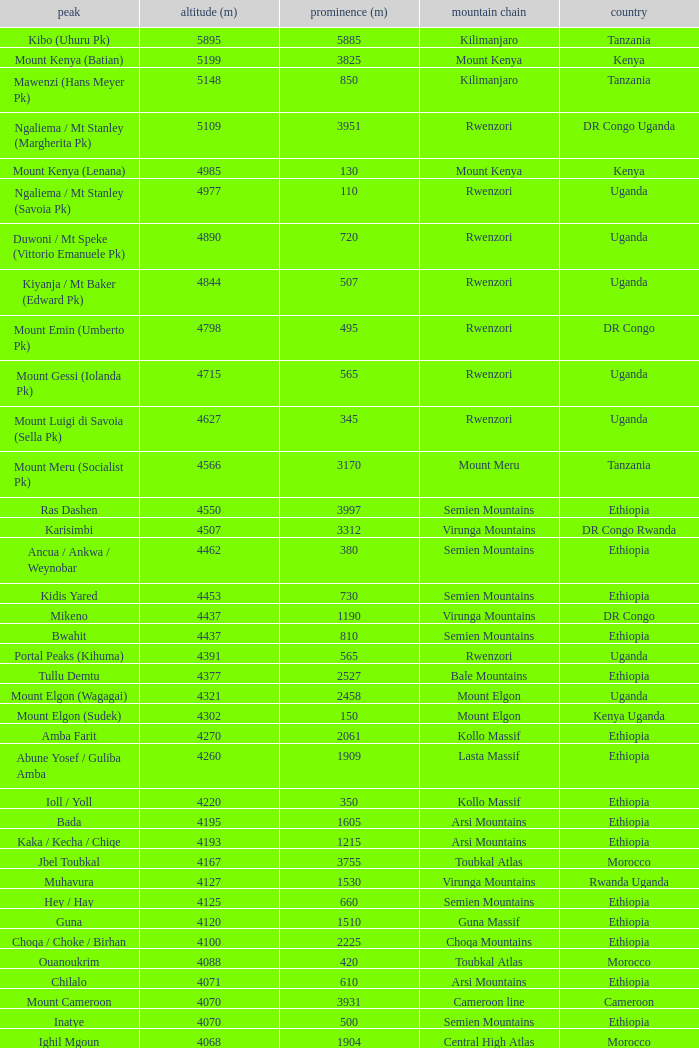Help me parse the entirety of this table. {'header': ['peak', 'altitude (m)', 'prominence (m)', 'mountain chain', 'country'], 'rows': [['Kibo (Uhuru Pk)', '5895', '5885', 'Kilimanjaro', 'Tanzania'], ['Mount Kenya (Batian)', '5199', '3825', 'Mount Kenya', 'Kenya'], ['Mawenzi (Hans Meyer Pk)', '5148', '850', 'Kilimanjaro', 'Tanzania'], ['Ngaliema / Mt Stanley (Margherita Pk)', '5109', '3951', 'Rwenzori', 'DR Congo Uganda'], ['Mount Kenya (Lenana)', '4985', '130', 'Mount Kenya', 'Kenya'], ['Ngaliema / Mt Stanley (Savoia Pk)', '4977', '110', 'Rwenzori', 'Uganda'], ['Duwoni / Mt Speke (Vittorio Emanuele Pk)', '4890', '720', 'Rwenzori', 'Uganda'], ['Kiyanja / Mt Baker (Edward Pk)', '4844', '507', 'Rwenzori', 'Uganda'], ['Mount Emin (Umberto Pk)', '4798', '495', 'Rwenzori', 'DR Congo'], ['Mount Gessi (Iolanda Pk)', '4715', '565', 'Rwenzori', 'Uganda'], ['Mount Luigi di Savoia (Sella Pk)', '4627', '345', 'Rwenzori', 'Uganda'], ['Mount Meru (Socialist Pk)', '4566', '3170', 'Mount Meru', 'Tanzania'], ['Ras Dashen', '4550', '3997', 'Semien Mountains', 'Ethiopia'], ['Karisimbi', '4507', '3312', 'Virunga Mountains', 'DR Congo Rwanda'], ['Ancua / Ankwa / Weynobar', '4462', '380', 'Semien Mountains', 'Ethiopia'], ['Kidis Yared', '4453', '730', 'Semien Mountains', 'Ethiopia'], ['Mikeno', '4437', '1190', 'Virunga Mountains', 'DR Congo'], ['Bwahit', '4437', '810', 'Semien Mountains', 'Ethiopia'], ['Portal Peaks (Kihuma)', '4391', '565', 'Rwenzori', 'Uganda'], ['Tullu Demtu', '4377', '2527', 'Bale Mountains', 'Ethiopia'], ['Mount Elgon (Wagagai)', '4321', '2458', 'Mount Elgon', 'Uganda'], ['Mount Elgon (Sudek)', '4302', '150', 'Mount Elgon', 'Kenya Uganda'], ['Amba Farit', '4270', '2061', 'Kollo Massif', 'Ethiopia'], ['Abune Yosef / Guliba Amba', '4260', '1909', 'Lasta Massif', 'Ethiopia'], ['Ioll / Yoll', '4220', '350', 'Kollo Massif', 'Ethiopia'], ['Bada', '4195', '1605', 'Arsi Mountains', 'Ethiopia'], ['Kaka / Kecha / Chiqe', '4193', '1215', 'Arsi Mountains', 'Ethiopia'], ['Jbel Toubkal', '4167', '3755', 'Toubkal Atlas', 'Morocco'], ['Muhavura', '4127', '1530', 'Virunga Mountains', 'Rwanda Uganda'], ['Hey / Hay', '4125', '660', 'Semien Mountains', 'Ethiopia'], ['Guna', '4120', '1510', 'Guna Massif', 'Ethiopia'], ['Choqa / Choke / Birhan', '4100', '2225', 'Choqa Mountains', 'Ethiopia'], ['Ouanoukrim', '4088', '420', 'Toubkal Atlas', 'Morocco'], ['Chilalo', '4071', '610', 'Arsi Mountains', 'Ethiopia'], ['Mount Cameroon', '4070', '3931', 'Cameroon line', 'Cameroon'], ['Inatye', '4070', '500', 'Semien Mountains', 'Ethiopia'], ['Ighil Mgoun', '4068', '1904', 'Central High Atlas', 'Morocco'], ['Weshema / Wasema?', '4030', '420', 'Bale Mountains', 'Ethiopia'], ['Oldoinyo Lesatima', '4001', '2081', 'Aberdare Range', 'Kenya'], ["Jebel n'Tarourt / Tifnout / Iferouane", '3996', '910', 'Toubkal Atlas', 'Morocco'], ['Muggia', '3950', '500', 'Lasta Massif', 'Ethiopia'], ['Dubbai', '3941', '1540', 'Tigray Mountains', 'Ethiopia'], ['Taska n’Zat', '3912', '460', 'Toubkal Atlas', 'Morocco'], ['Aksouâl', '3903', '450', 'Toubkal Atlas', 'Morocco'], ['Mount Kinangop', '3902', '530', 'Aberdare Range', 'Kenya'], ['Cimbia', '3900', '590', 'Kollo Massif', 'Ethiopia'], ['Anrhemer / Ingehmar', '3892', '380', 'Toubkal Atlas', 'Morocco'], ['Ieciuol ?', '3840', '560', 'Kollo Massif', 'Ethiopia'], ['Kawa / Caua / Lajo', '3830', '475', 'Bale Mountains', 'Ethiopia'], ['Pt 3820', '3820', '450', 'Kollo Massif', 'Ethiopia'], ['Jbel Tignousti', '3819', '930', 'Central High Atlas', 'Morocco'], ['Filfo / Encuolo', '3805', '770', 'Arsi Mountains', 'Ethiopia'], ['Kosso Amba', '3805', '530', 'Lasta Massif', 'Ethiopia'], ['Jbel Ghat', '3781', '470', 'Central High Atlas', 'Morocco'], ['Baylamtu / Gavsigivla', '3777', '1120', 'Lasta Massif', 'Ethiopia'], ['Ouaougoulzat', '3763', '860', 'Central High Atlas', 'Morocco'], ['Somkaru', '3760', '530', 'Bale Mountains', 'Ethiopia'], ['Abieri', '3750', '780', 'Semien Mountains', 'Ethiopia'], ['Arin Ayachi', '3747', '1400', 'East High Atlas', 'Morocco'], ['Teide', '3718', '3718', 'Tenerife', 'Canary Islands'], ['Visoke / Bisoke', '3711', '585', 'Virunga Mountains', 'DR Congo Rwanda'], ['Sarenga', '3700', '1160', 'Tigray Mountains', 'Ethiopia'], ['Woti / Uoti', '3700', '1050', 'Eastern Escarpment', 'Ethiopia'], ['Pt 3700 (Kulsa?)', '3700', '490', 'Arsi Mountains', 'Ethiopia'], ['Loolmalassin', '3682', '2040', 'Crater Highlands', 'Tanzania'], ['Biala ?', '3680', '870', 'Lasta Massif', 'Ethiopia'], ['Azurki / Azourki', '3677', '790', 'Central High Atlas', 'Morocco'], ['Pt 3645', '3645', '910', 'Lasta Massif', 'Ethiopia'], ['Sabyinyo', '3634', '1010', 'Virunga Mountains', 'Rwanda DR Congo Uganda'], ['Mount Gurage / Guraghe', '3620', '1400', 'Gurage Mountains', 'Ethiopia'], ['Angour', '3616', '444', 'Toubkal Atlas', 'Morocco'], ['Jbel Igdat', '3615', '1609', 'West High Atlas', 'Morocco'], ["Jbel n'Anghomar", '3609', '1420', 'Central High Atlas', 'Morocco'], ['Yegura / Amba Moka', '3605', '420', 'Lasta Massif', 'Ethiopia'], ['Pt 3600 (Kitir?)', '3600', '870', 'Eastern Escarpment', 'Ethiopia'], ['Pt 3600', '3600', '610', 'Lasta Massif', 'Ethiopia'], ['Bar Meda high point', '3580', '520', 'Eastern Escarpment', 'Ethiopia'], ['Jbel Erdouz', '3579', '690', 'West High Atlas', 'Morocco'], ['Mount Gugu', '3570', '940', 'Mount Gugu', 'Ethiopia'], ['Gesh Megal (?)', '3570', '520', 'Gurage Mountains', 'Ethiopia'], ['Gughe', '3568', '2013', 'Balta Mountains', 'Ethiopia'], ['Megezez', '3565', '690', 'Eastern Escarpment', 'Ethiopia'], ['Pt 3555', '3555', '475', 'Lasta Massif', 'Ethiopia'], ['Jbel Tinergwet', '3551', '880', 'West High Atlas', 'Morocco'], ['Amba Alagi', '3550', '820', 'Tigray Mountains', 'Ethiopia'], ['Nakugen', '3530', '1510', 'Cherangany Hills', 'Kenya'], ['Gara Guda /Kara Gada', '3530', '900', 'Salale Mountains', 'Ethiopia'], ['Amonewas', '3530', '870', 'Choqa Mountains', 'Ethiopia'], ['Amedamit', '3530', '760', 'Choqa Mountains', 'Ethiopia'], ['Igoudamene', '3519', '550', 'Central High Atlas', 'Morocco'], ['Abuye Meda', '3505', '230', 'Eastern Escarpment', 'Ethiopia'], ['Thabana Ntlenyana', '3482', '2390', 'Drakensberg', 'Lesotho'], ['Mont Mohi', '3480', '1592', 'Mitumba Mountains', 'DR Congo'], ['Gahinga', '3474', '425', 'Virunga Mountains', 'Uganda Rwanda'], ['Nyiragongo', '3470', '1440', 'Virunga Mountains', 'DR Congo']]} Which Country has a Height (m) larger than 4100, and a Range of arsi mountains, and a Mountain of bada? Ethiopia. 